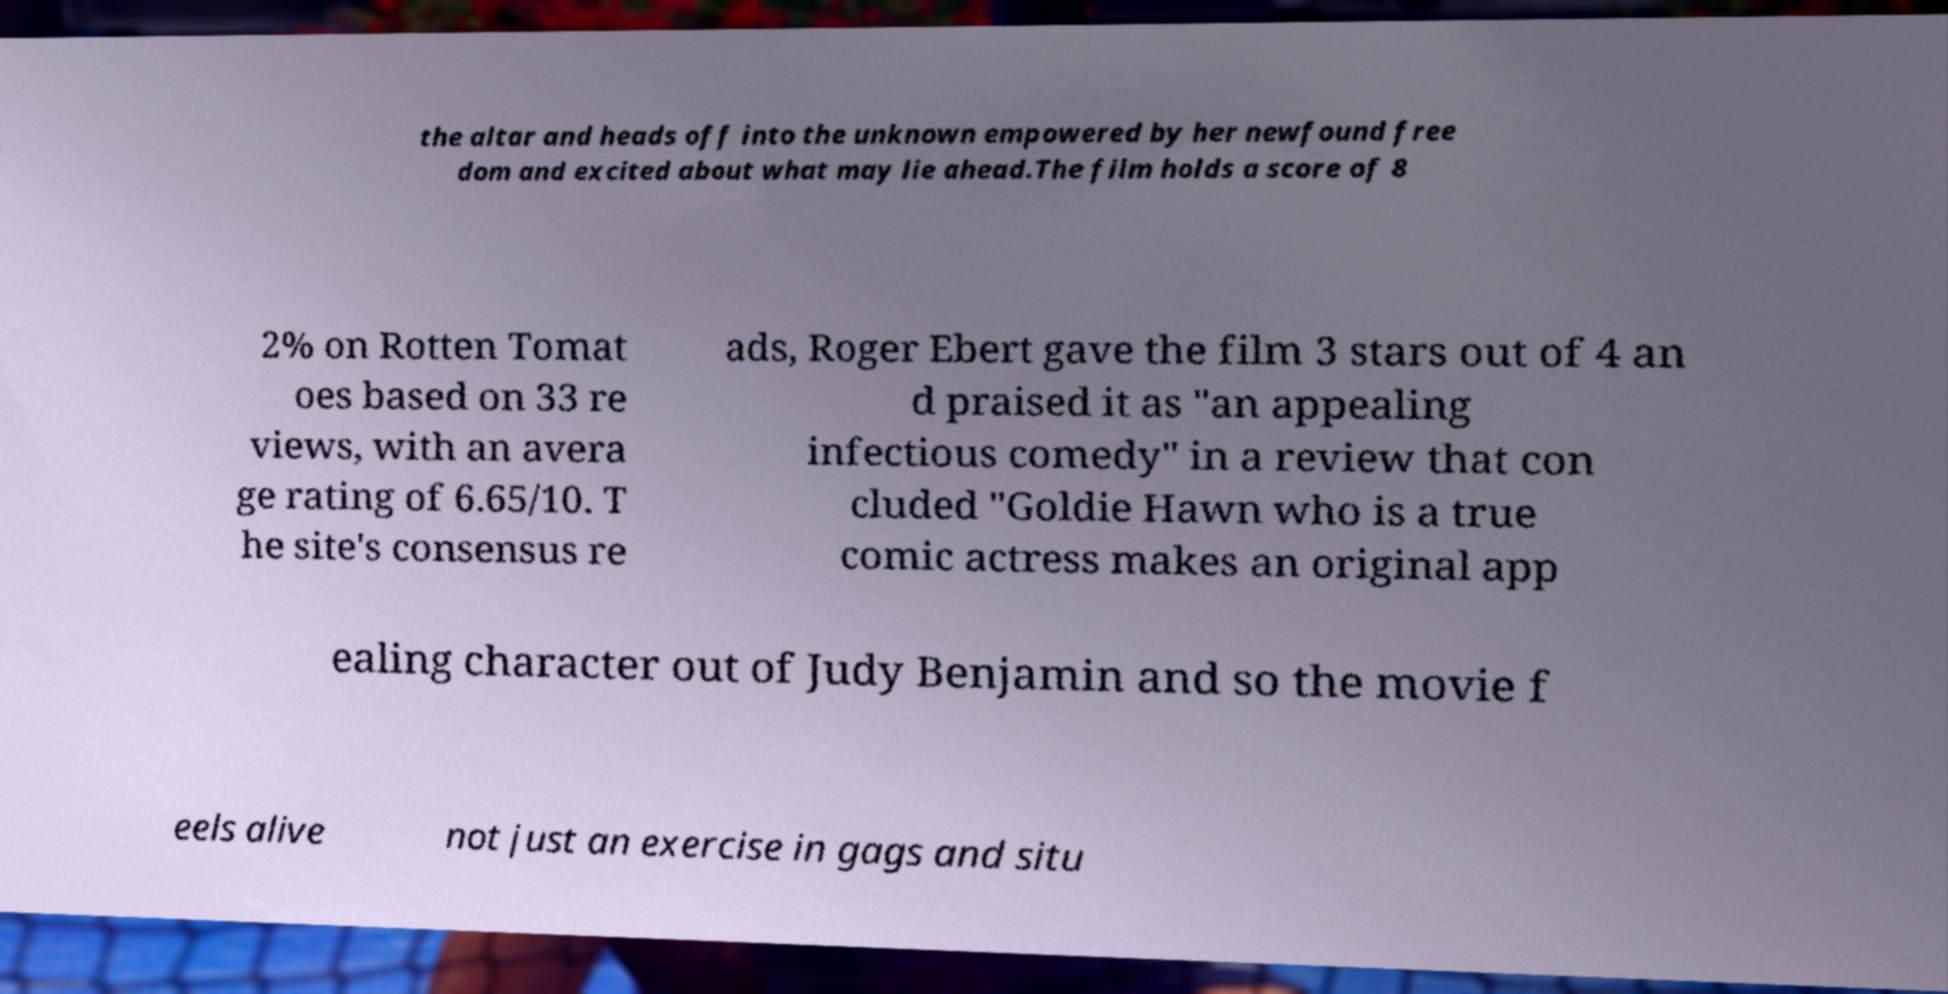There's text embedded in this image that I need extracted. Can you transcribe it verbatim? the altar and heads off into the unknown empowered by her newfound free dom and excited about what may lie ahead.The film holds a score of 8 2% on Rotten Tomat oes based on 33 re views, with an avera ge rating of 6.65/10. T he site's consensus re ads, Roger Ebert gave the film 3 stars out of 4 an d praised it as "an appealing infectious comedy" in a review that con cluded "Goldie Hawn who is a true comic actress makes an original app ealing character out of Judy Benjamin and so the movie f eels alive not just an exercise in gags and situ 